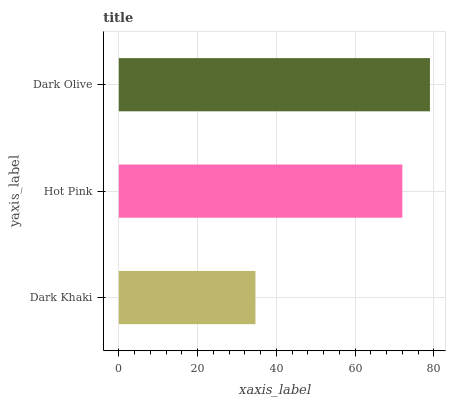Is Dark Khaki the minimum?
Answer yes or no. Yes. Is Dark Olive the maximum?
Answer yes or no. Yes. Is Hot Pink the minimum?
Answer yes or no. No. Is Hot Pink the maximum?
Answer yes or no. No. Is Hot Pink greater than Dark Khaki?
Answer yes or no. Yes. Is Dark Khaki less than Hot Pink?
Answer yes or no. Yes. Is Dark Khaki greater than Hot Pink?
Answer yes or no. No. Is Hot Pink less than Dark Khaki?
Answer yes or no. No. Is Hot Pink the high median?
Answer yes or no. Yes. Is Hot Pink the low median?
Answer yes or no. Yes. Is Dark Khaki the high median?
Answer yes or no. No. Is Dark Olive the low median?
Answer yes or no. No. 